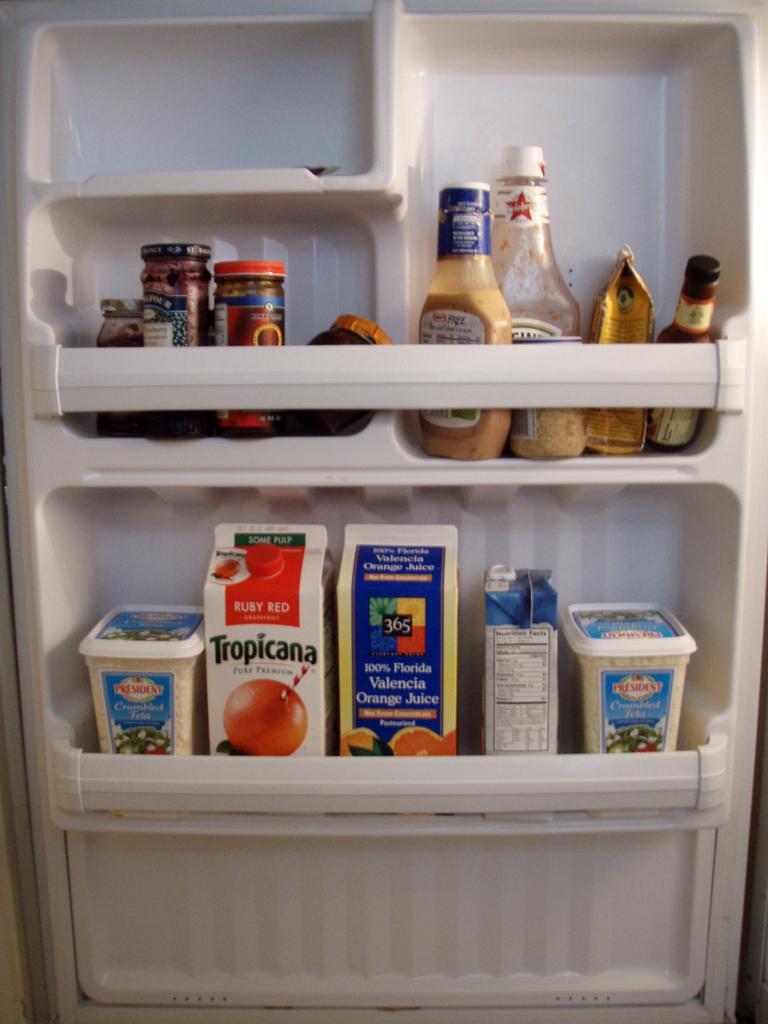Please provide a concise description of this image. In the foreground of this image, there are bottles, tetra packs and containers in a fridge door. 